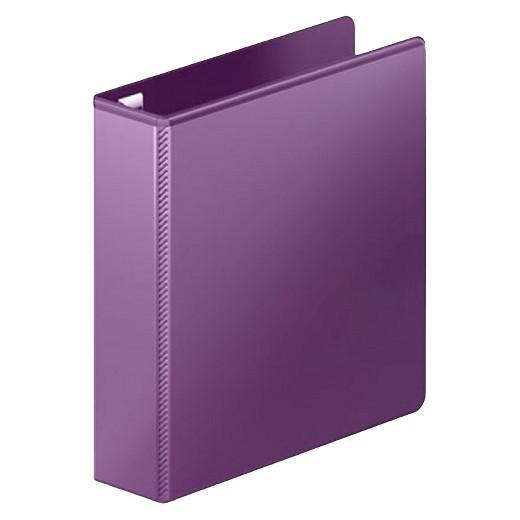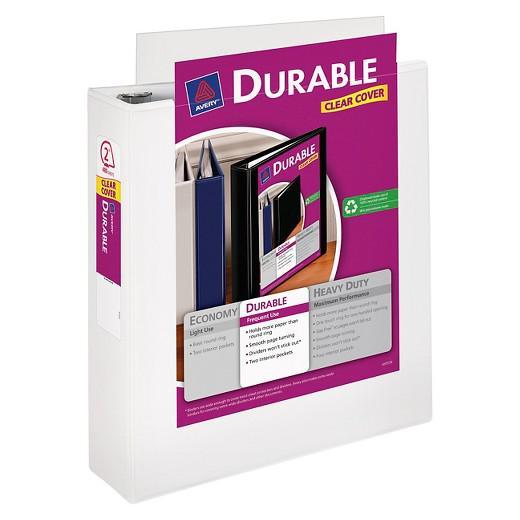The first image is the image on the left, the second image is the image on the right. Given the left and right images, does the statement "All binders are the base color white and there are at least five present." hold true? Answer yes or no. No. The first image is the image on the left, the second image is the image on the right. Analyze the images presented: Is the assertion "All binders shown are white and all binders are displayed upright." valid? Answer yes or no. No. 